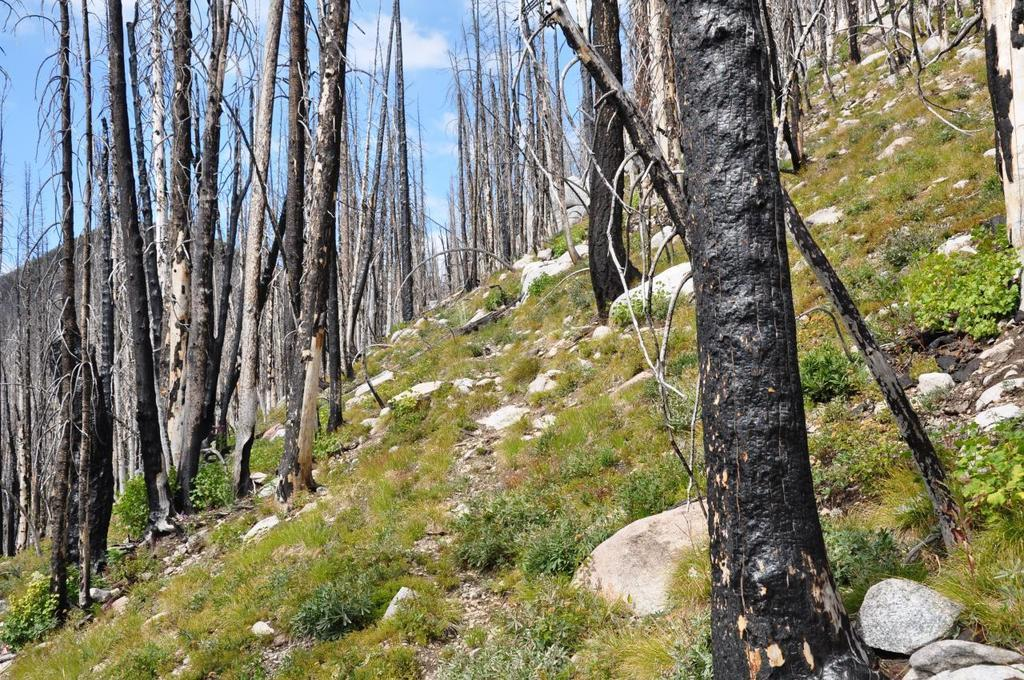What type of vegetation can be seen in the image? There are many trees, plants, and grass in the image. What other elements can be found in the image? There are stones in the image. What is visible in the background of the image? The sky is visible in the background of the image. How many babies are crawling on the grass in the image? There are no babies present in the image; it features trees, plants, grass, stones, and the sky. 